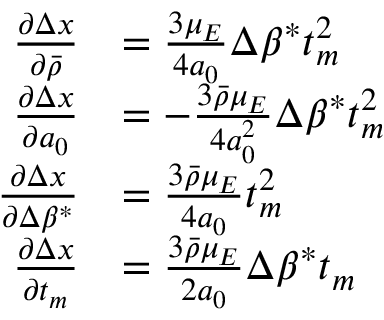Convert formula to latex. <formula><loc_0><loc_0><loc_500><loc_500>\begin{array} { r l } { \frac { \partial \Delta x } { \partial \bar { \rho } } } & { = \frac { 3 \mu _ { E } } { 4 a _ { 0 } } \Delta \beta ^ { * } t _ { m } ^ { 2 } } \\ { \frac { \partial \Delta x } { \partial a _ { 0 } } } & { = - \frac { 3 \bar { \rho } \mu _ { E } } { 4 a _ { 0 } ^ { 2 } } \Delta \beta ^ { * } t _ { m } ^ { 2 } } \\ { \frac { \partial \Delta x } { \partial \Delta \beta ^ { * } } } & { = \frac { 3 \bar { \rho } \mu _ { E } } { 4 a _ { 0 } } t _ { m } ^ { 2 } } \\ { \frac { \partial \Delta x } { \partial t _ { m } } } & { = \frac { 3 \bar { \rho } \mu _ { E } } { 2 a _ { 0 } } \Delta \beta ^ { * } t _ { m } } \end{array}</formula> 